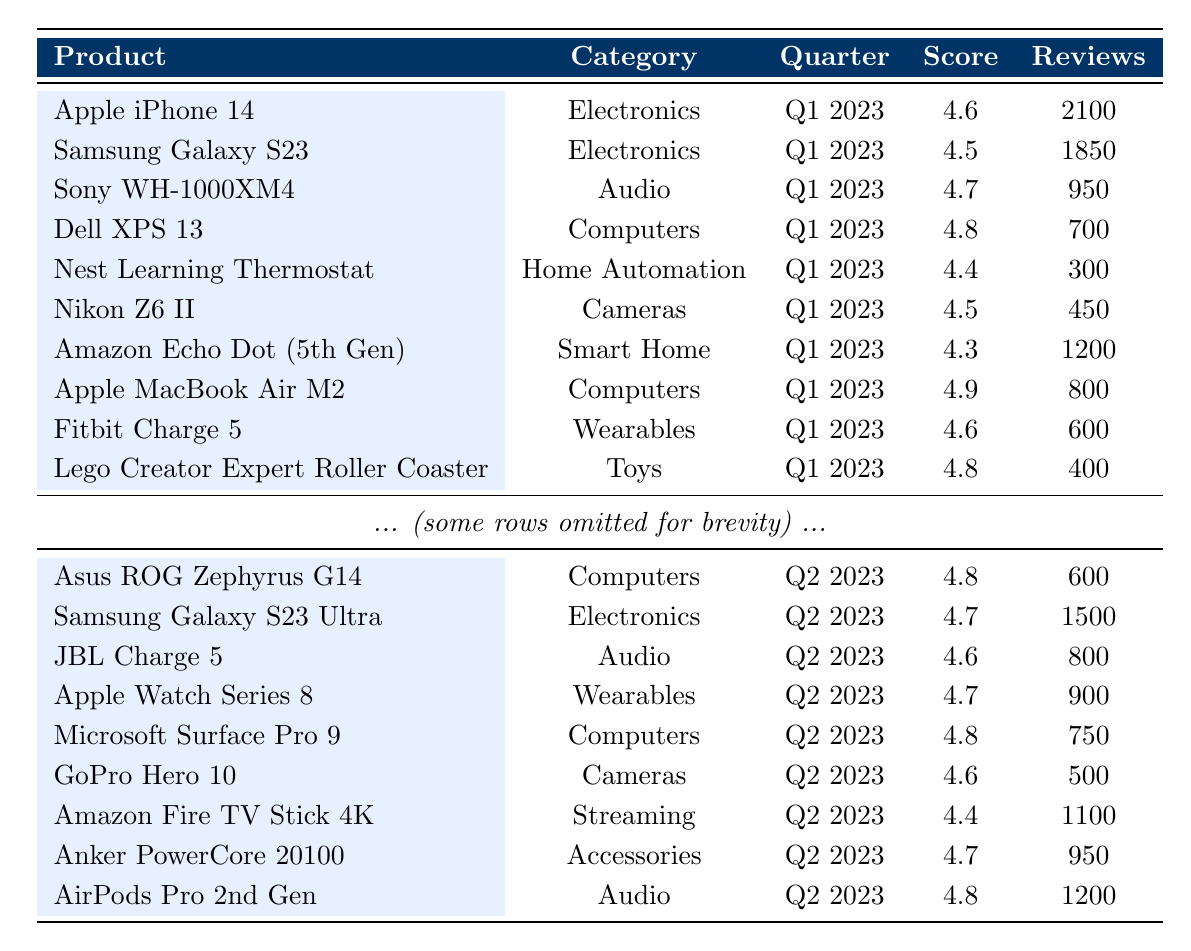What is the highest score achieved by any product in Q1 2023? Looking at the scores for Q1 2023, the highest score is 4.9, which is achieved by the Apple MacBook Air M2 and Canon EOS R5.
Answer: 4.9 Which product in the "Wearables" category has the highest review count in Q2 2023? In the "Wearables" category for Q2 2023, the Apple Watch Series 8 has the highest review count of 900.
Answer: Apple Watch Series 8 How many total reviews are there for all products in Q1 2023? Adding the review counts for Q1 2023: 2100 + 1850 + 950 + 700 + 300 + 450 + 1200 + 800 + 600 + 400 + 550 + 1200 + 500 + 700 + 300 + 230 + 920 = 14900.
Answer: 14900 Is the average score of products in the "Audio" category greater than 4.5 in Q2 2023? The scores for Audio products in Q2 2023 are 4.6 (JBL Charge 5) and 4.8 (AirPods Pro 2nd Gen). The average score is (4.6 + 4.8) / 2 = 4.7, which is greater than 4.5.
Answer: Yes What is the total score of all products in the "Computers" category across both quarters? For Q1 2023, the scores for Computers are: 4.8 (Dell XPS 13) + 4.9 (Apple MacBook Air M2) + 4.4 (HP Omen 15) = 14.1. For Q2 2023: 4.8 (Asus ROG Zephyrus G14) + 4.8 (Microsoft Surface Pro 9) = 9.6. The total is 14.1 + 9.6 = 23.7.
Answer: 23.7 Which product has the lowest score in the "Smart Home" category? The only product listed in the "Smart Home" category is Amazon Echo Dot (5th Gen), with a score of 4.3.
Answer: Amazon Echo Dot (5th Gen) What percentage of reviews for products in the "Electronics" category is from Q2 2023? In Q1 2023, the total reviews for Electronics (2100 + 1850 = 3950). In Q2 2023, there are 1500 reviews for Samsung Galaxy S23 Ultra. To find the percentage: (1500 / (3950 + 1500)) * 100 = 27.5%.
Answer: 27.5% Find the product with the highest review count and state its score. Looking through the review counts, Apple iPhone 14 has the highest with 2100 reviews and a score of 4.6.
Answer: Apple iPhone 14, 4.6 Which product's scores decreased from Q1 to Q2 2023? Comparing the scores, Samsung Galaxy S23 scored 4.5 in Q1 and 4.7 in Q2, which is an increase. Therefore, no product shows a decrease in scores from Q1 to Q2.
Answer: None 